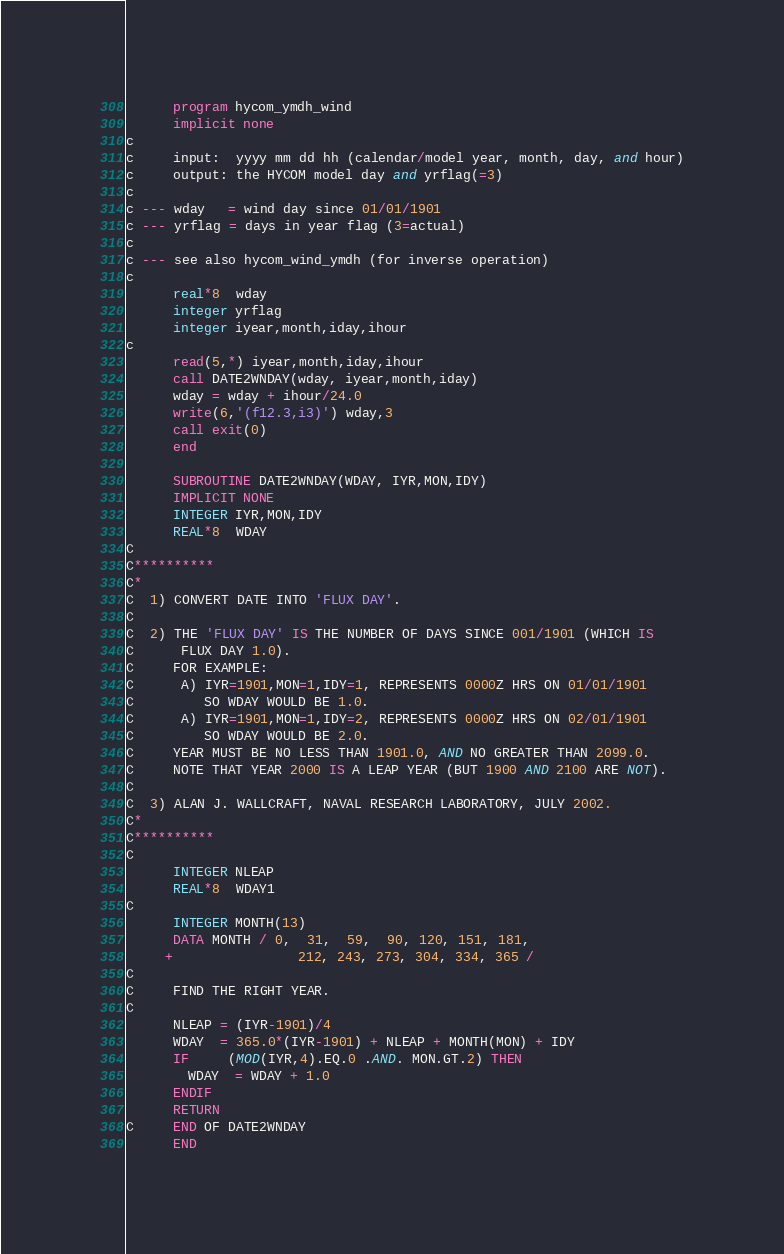<code> <loc_0><loc_0><loc_500><loc_500><_FORTRAN_>      program hycom_ymdh_wind
      implicit none
c
c     input:  yyyy mm dd hh (calendar/model year, month, day, and hour)
c     output: the HYCOM model day and yrflag(=3)
c
c --- wday   = wind day since 01/01/1901
c --- yrflag = days in year flag (3=actual)
c
c --- see also hycom_wind_ymdh (for inverse operation)
c
      real*8  wday
      integer yrflag
      integer iyear,month,iday,ihour
c
      read(5,*) iyear,month,iday,ihour
      call DATE2WNDAY(wday, iyear,month,iday)
      wday = wday + ihour/24.0
      write(6,'(f12.3,i3)') wday,3
      call exit(0)
      end

      SUBROUTINE DATE2WNDAY(WDAY, IYR,MON,IDY)
      IMPLICIT NONE
      INTEGER IYR,MON,IDY
      REAL*8  WDAY
C
C**********
C*
C  1) CONVERT DATE INTO 'FLUX DAY'.
C
C  2) THE 'FLUX DAY' IS THE NUMBER OF DAYS SINCE 001/1901 (WHICH IS 
C      FLUX DAY 1.0).
C     FOR EXAMPLE:
C      A) IYR=1901,MON=1,IDY=1, REPRESENTS 0000Z HRS ON 01/01/1901
C         SO WDAY WOULD BE 1.0.
C      A) IYR=1901,MON=1,IDY=2, REPRESENTS 0000Z HRS ON 02/01/1901
C         SO WDAY WOULD BE 2.0.
C     YEAR MUST BE NO LESS THAN 1901.0, AND NO GREATER THAN 2099.0.
C     NOTE THAT YEAR 2000 IS A LEAP YEAR (BUT 1900 AND 2100 ARE NOT).
C
C  3) ALAN J. WALLCRAFT, NAVAL RESEARCH LABORATORY, JULY 2002.
C*
C**********
C
      INTEGER NLEAP
      REAL*8  WDAY1
C
      INTEGER MONTH(13)
      DATA MONTH / 0,  31,  59,  90, 120, 151, 181,
     +                212, 243, 273, 304, 334, 365 /
C
C     FIND THE RIGHT YEAR.
C
      NLEAP = (IYR-1901)/4
      WDAY  = 365.0*(IYR-1901) + NLEAP + MONTH(MON) + IDY
      IF     (MOD(IYR,4).EQ.0 .AND. MON.GT.2) THEN
        WDAY  = WDAY + 1.0
      ENDIF
      RETURN
C     END OF DATE2WNDAY
      END
</code> 